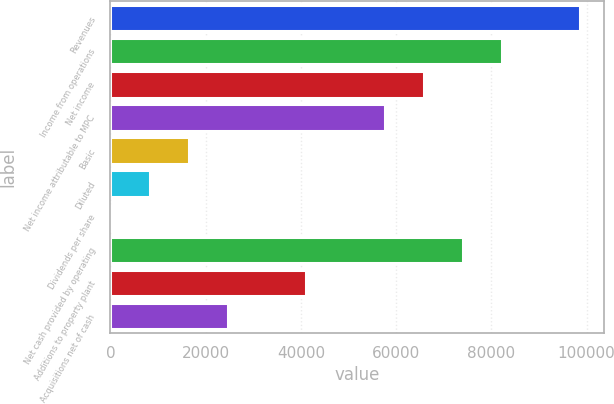Convert chart to OTSL. <chart><loc_0><loc_0><loc_500><loc_500><bar_chart><fcel>Revenues<fcel>Income from operations<fcel>Net income<fcel>Net income attributable to MPC<fcel>Basic<fcel>Diluted<fcel>Dividends per share<fcel>Net cash provided by operating<fcel>Additions to property plant<fcel>Acquisitions net of cash<nl><fcel>98691.5<fcel>82243<fcel>65794.5<fcel>57570.3<fcel>16449.1<fcel>8224.84<fcel>0.6<fcel>74018.8<fcel>41121.8<fcel>24673.3<nl></chart> 